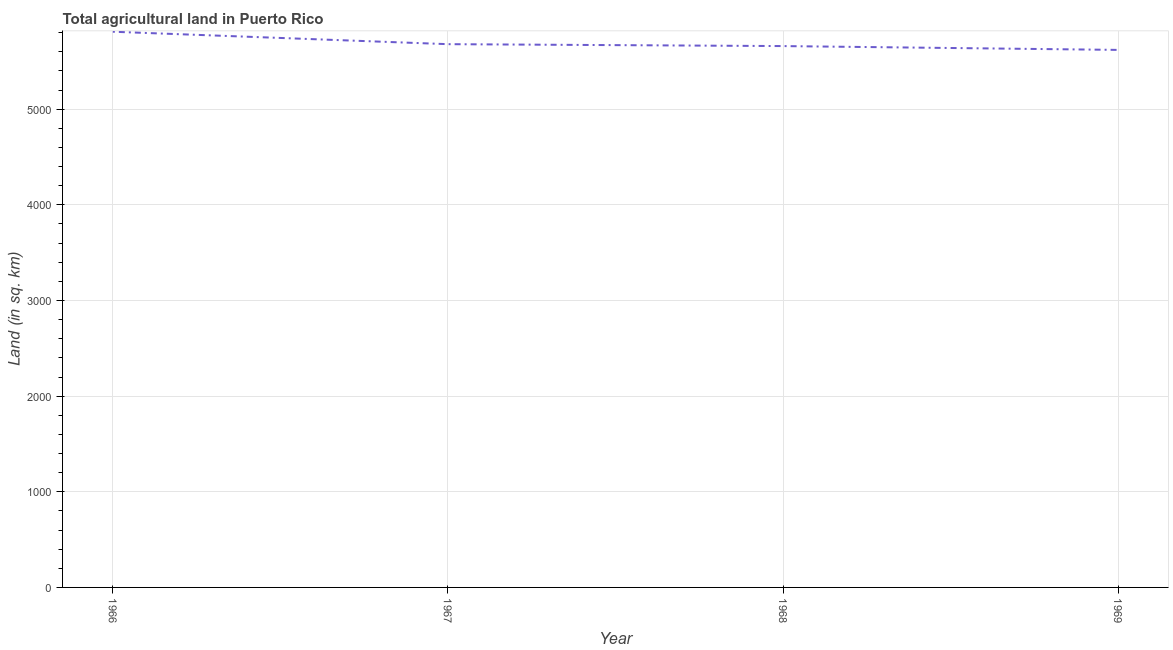What is the agricultural land in 1967?
Provide a short and direct response. 5680. Across all years, what is the maximum agricultural land?
Provide a short and direct response. 5810. Across all years, what is the minimum agricultural land?
Keep it short and to the point. 5620. In which year was the agricultural land maximum?
Provide a short and direct response. 1966. In which year was the agricultural land minimum?
Your answer should be very brief. 1969. What is the sum of the agricultural land?
Ensure brevity in your answer.  2.28e+04. What is the difference between the agricultural land in 1966 and 1968?
Offer a terse response. 150. What is the average agricultural land per year?
Offer a terse response. 5692.5. What is the median agricultural land?
Your answer should be compact. 5670. In how many years, is the agricultural land greater than 5200 sq. km?
Your answer should be compact. 4. Do a majority of the years between 1967 and 1969 (inclusive) have agricultural land greater than 4400 sq. km?
Ensure brevity in your answer.  Yes. What is the ratio of the agricultural land in 1967 to that in 1968?
Offer a terse response. 1. Is the agricultural land in 1966 less than that in 1967?
Your answer should be compact. No. Is the difference between the agricultural land in 1967 and 1969 greater than the difference between any two years?
Your answer should be very brief. No. What is the difference between the highest and the second highest agricultural land?
Your response must be concise. 130. Is the sum of the agricultural land in 1967 and 1968 greater than the maximum agricultural land across all years?
Provide a short and direct response. Yes. What is the difference between the highest and the lowest agricultural land?
Your answer should be compact. 190. How many years are there in the graph?
Ensure brevity in your answer.  4. What is the difference between two consecutive major ticks on the Y-axis?
Ensure brevity in your answer.  1000. Are the values on the major ticks of Y-axis written in scientific E-notation?
Offer a very short reply. No. Does the graph contain grids?
Keep it short and to the point. Yes. What is the title of the graph?
Provide a succinct answer. Total agricultural land in Puerto Rico. What is the label or title of the Y-axis?
Ensure brevity in your answer.  Land (in sq. km). What is the Land (in sq. km) in 1966?
Your answer should be very brief. 5810. What is the Land (in sq. km) of 1967?
Make the answer very short. 5680. What is the Land (in sq. km) of 1968?
Provide a succinct answer. 5660. What is the Land (in sq. km) of 1969?
Provide a short and direct response. 5620. What is the difference between the Land (in sq. km) in 1966 and 1967?
Give a very brief answer. 130. What is the difference between the Land (in sq. km) in 1966 and 1968?
Your answer should be very brief. 150. What is the difference between the Land (in sq. km) in 1966 and 1969?
Keep it short and to the point. 190. What is the ratio of the Land (in sq. km) in 1966 to that in 1968?
Ensure brevity in your answer.  1.03. What is the ratio of the Land (in sq. km) in 1966 to that in 1969?
Make the answer very short. 1.03. What is the ratio of the Land (in sq. km) in 1968 to that in 1969?
Your answer should be compact. 1.01. 